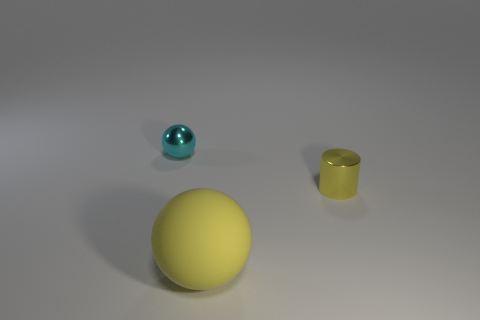What is the shape of the tiny object that is right of the object that is on the left side of the big yellow sphere?
Your answer should be compact. Cylinder. There is a object that is both behind the large rubber object and to the right of the shiny sphere; how big is it?
Offer a very short reply. Small. There is a big rubber thing; is its shape the same as the small shiny thing on the left side of the yellow matte sphere?
Provide a succinct answer. Yes. What size is the other rubber thing that is the same shape as the cyan thing?
Make the answer very short. Large. Is the color of the rubber object the same as the small thing in front of the tiny cyan object?
Keep it short and to the point. Yes. How many other things are there of the same size as the metal ball?
Your answer should be compact. 1. What shape is the yellow thing right of the sphere in front of the metal object that is behind the yellow cylinder?
Your answer should be very brief. Cylinder. Is the size of the cyan thing the same as the metallic object that is in front of the tiny ball?
Your answer should be very brief. Yes. There is a thing that is both right of the cyan shiny object and behind the matte sphere; what is its color?
Provide a short and direct response. Yellow. How many other objects are there of the same shape as the large yellow matte object?
Provide a short and direct response. 1. 